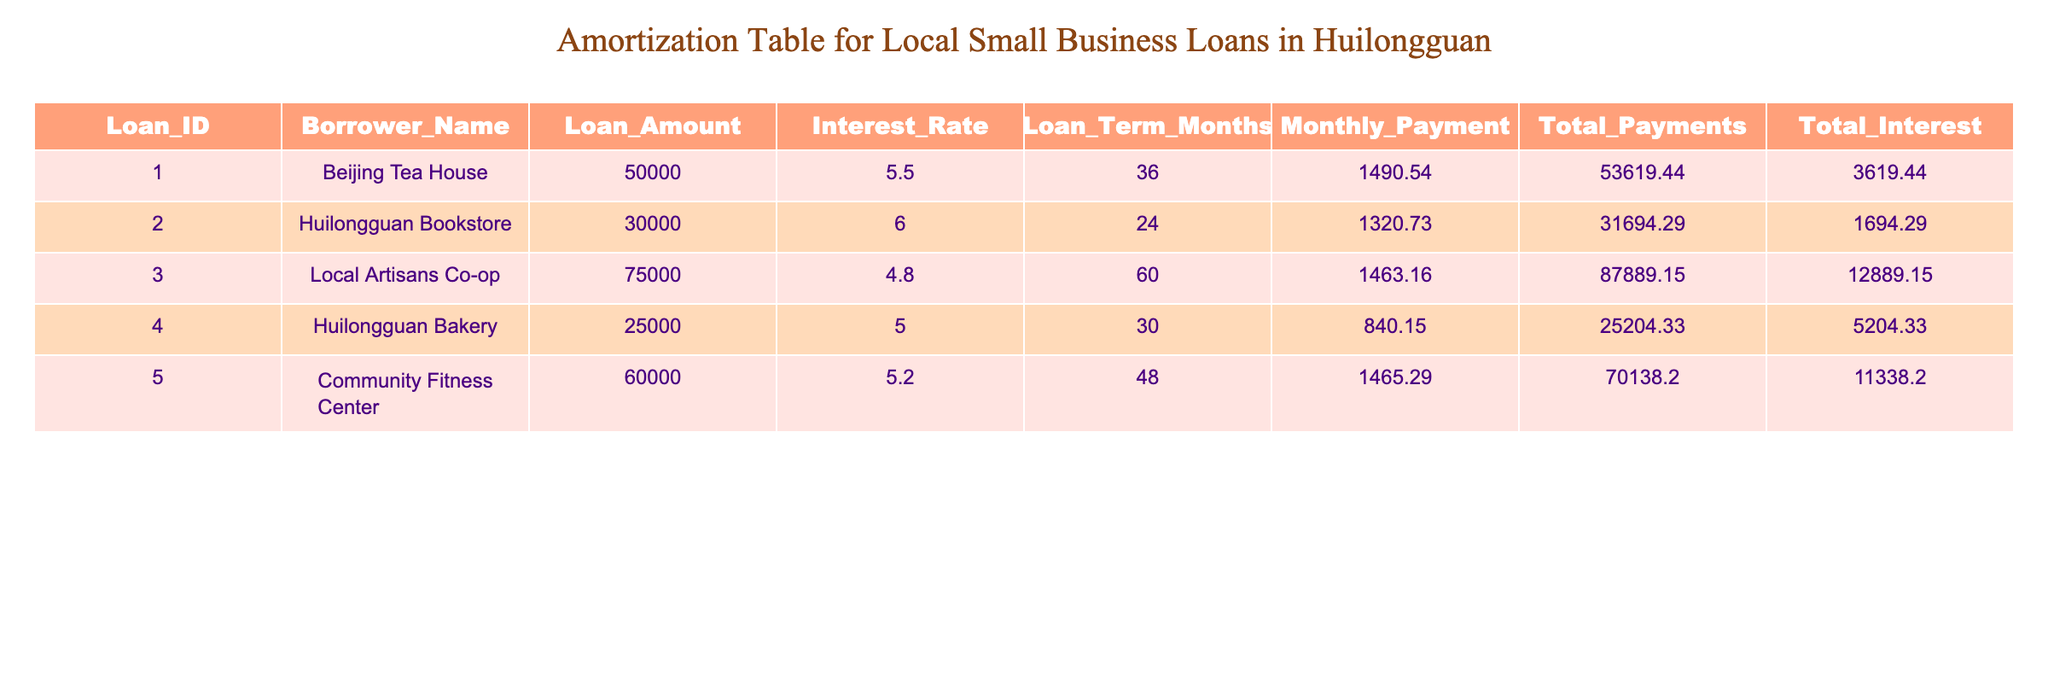What is the loan amount for Huilongguan Bakery? The loan amount for Huilongguan Bakery is listed directly in the table under the 'Loan_Amount' column. It shows as 25000.
Answer: 25000 What is the total interest paid by the Local Artisans Co-op? The total interest paid by the Local Artisans Co-op is found under the 'Total_Interest' column, which is listed as 12889.15.
Answer: 12889.15 Which borrower has the highest monthly payment? To find the borrower with the highest monthly payment, we compare the 'Monthly_Payment' values for each borrower. The maximum is 1490.54 for Beijing Tea House.
Answer: Beijing Tea House What is the average total payments for all the borrowers? To find the average total payments, we sum the 'Total_Payments' values (53619.44 + 31694.29 + 87889.15 + 25204.33 + 70138.20 = 218645.41) and divide it by the number of borrowers (5), resulting in 43729.08.
Answer: 43729.08 Does the Community Fitness Center have a lower interest rate compared to Huilongguan Bookstore? To assess this, we compare the 'Interest_Rate' for both borrowers. Community Fitness Center has 5.2, while Huilongguan Bookstore has 6.0. Since 5.2 is less than 6.0, the statement is true.
Answer: Yes What is the difference in total interest between Huilongguan Bookstore and Huilongguan Bakery? We find the 'Total_Interest' for both borrowers: Huilongguan Bookstore has 1694.29 and Huilongguan Bakery has 5204.33. The difference is 5204.33 - 1694.29 = 3510.04.
Answer: 3510.04 Which loan has the longest term and what is its amount? The term with the longest duration is found by identifying the maximum value in the 'Loan_Term_Months' column, which is 60 months, corresponding to the Local Artisans Co-op with a loan amount of 75000.
Answer: 75000 If the interest rate for Huilongguan Bakery were to increase by 1%, what would be its new interest rate? Huilongguan Bakery's current interest rate is 5.0. If it increases by 1%, we simply add 1 to 5.0 to get 6.0.
Answer: 6.0 What percentage of the total loan amount does the Huilongguan Bookstore represent? The total loan amount is 50000 + 30000 + 75000 + 25000 + 60000 = 240000. Huilongguan Bookstore’s loan amount is 30000. The percentage is (30000 / 240000) * 100 = 12.5%.
Answer: 12.5% 